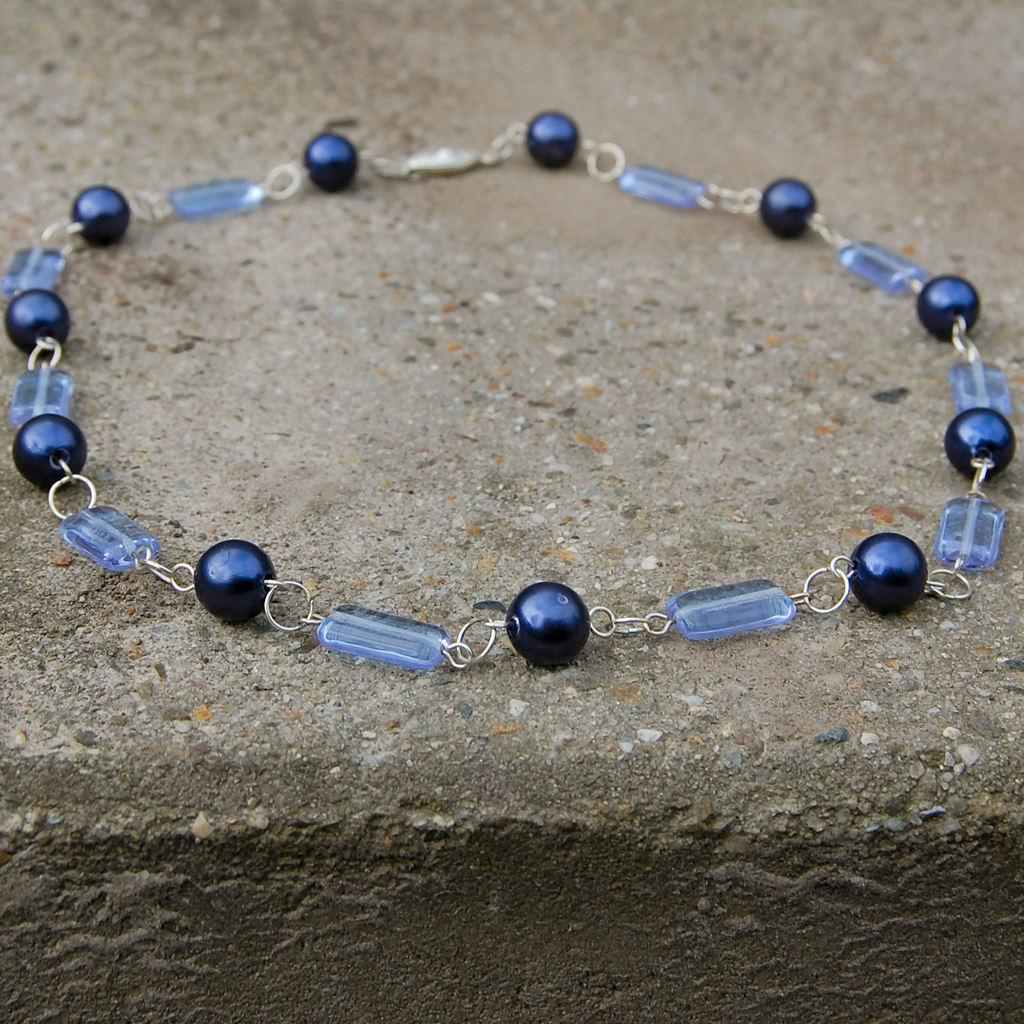What type of jewelry is present in the image? There is a bracelet in the image. What is the bracelet made of? The bracelet is made up of blue color beads. What can be seen at the bottom of the image? There is water visible at the bottom of the image. What type of appliance is floating in the water at the bottom of the image? There is no appliance present in the image; it only features a bracelet and water. 